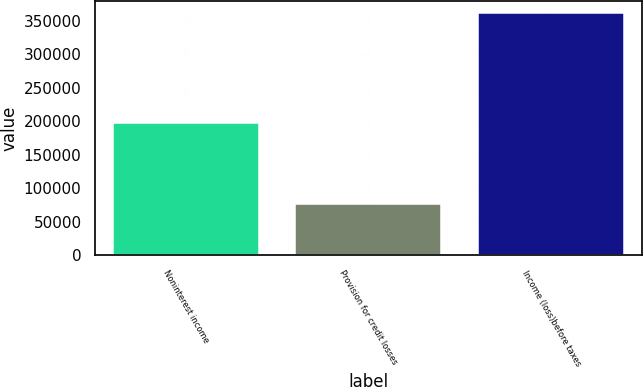Convert chart to OTSL. <chart><loc_0><loc_0><loc_500><loc_500><bar_chart><fcel>Noninterest income<fcel>Provision for credit losses<fcel>Income (loss)before taxes<nl><fcel>197515<fcel>77104<fcel>361305<nl></chart> 